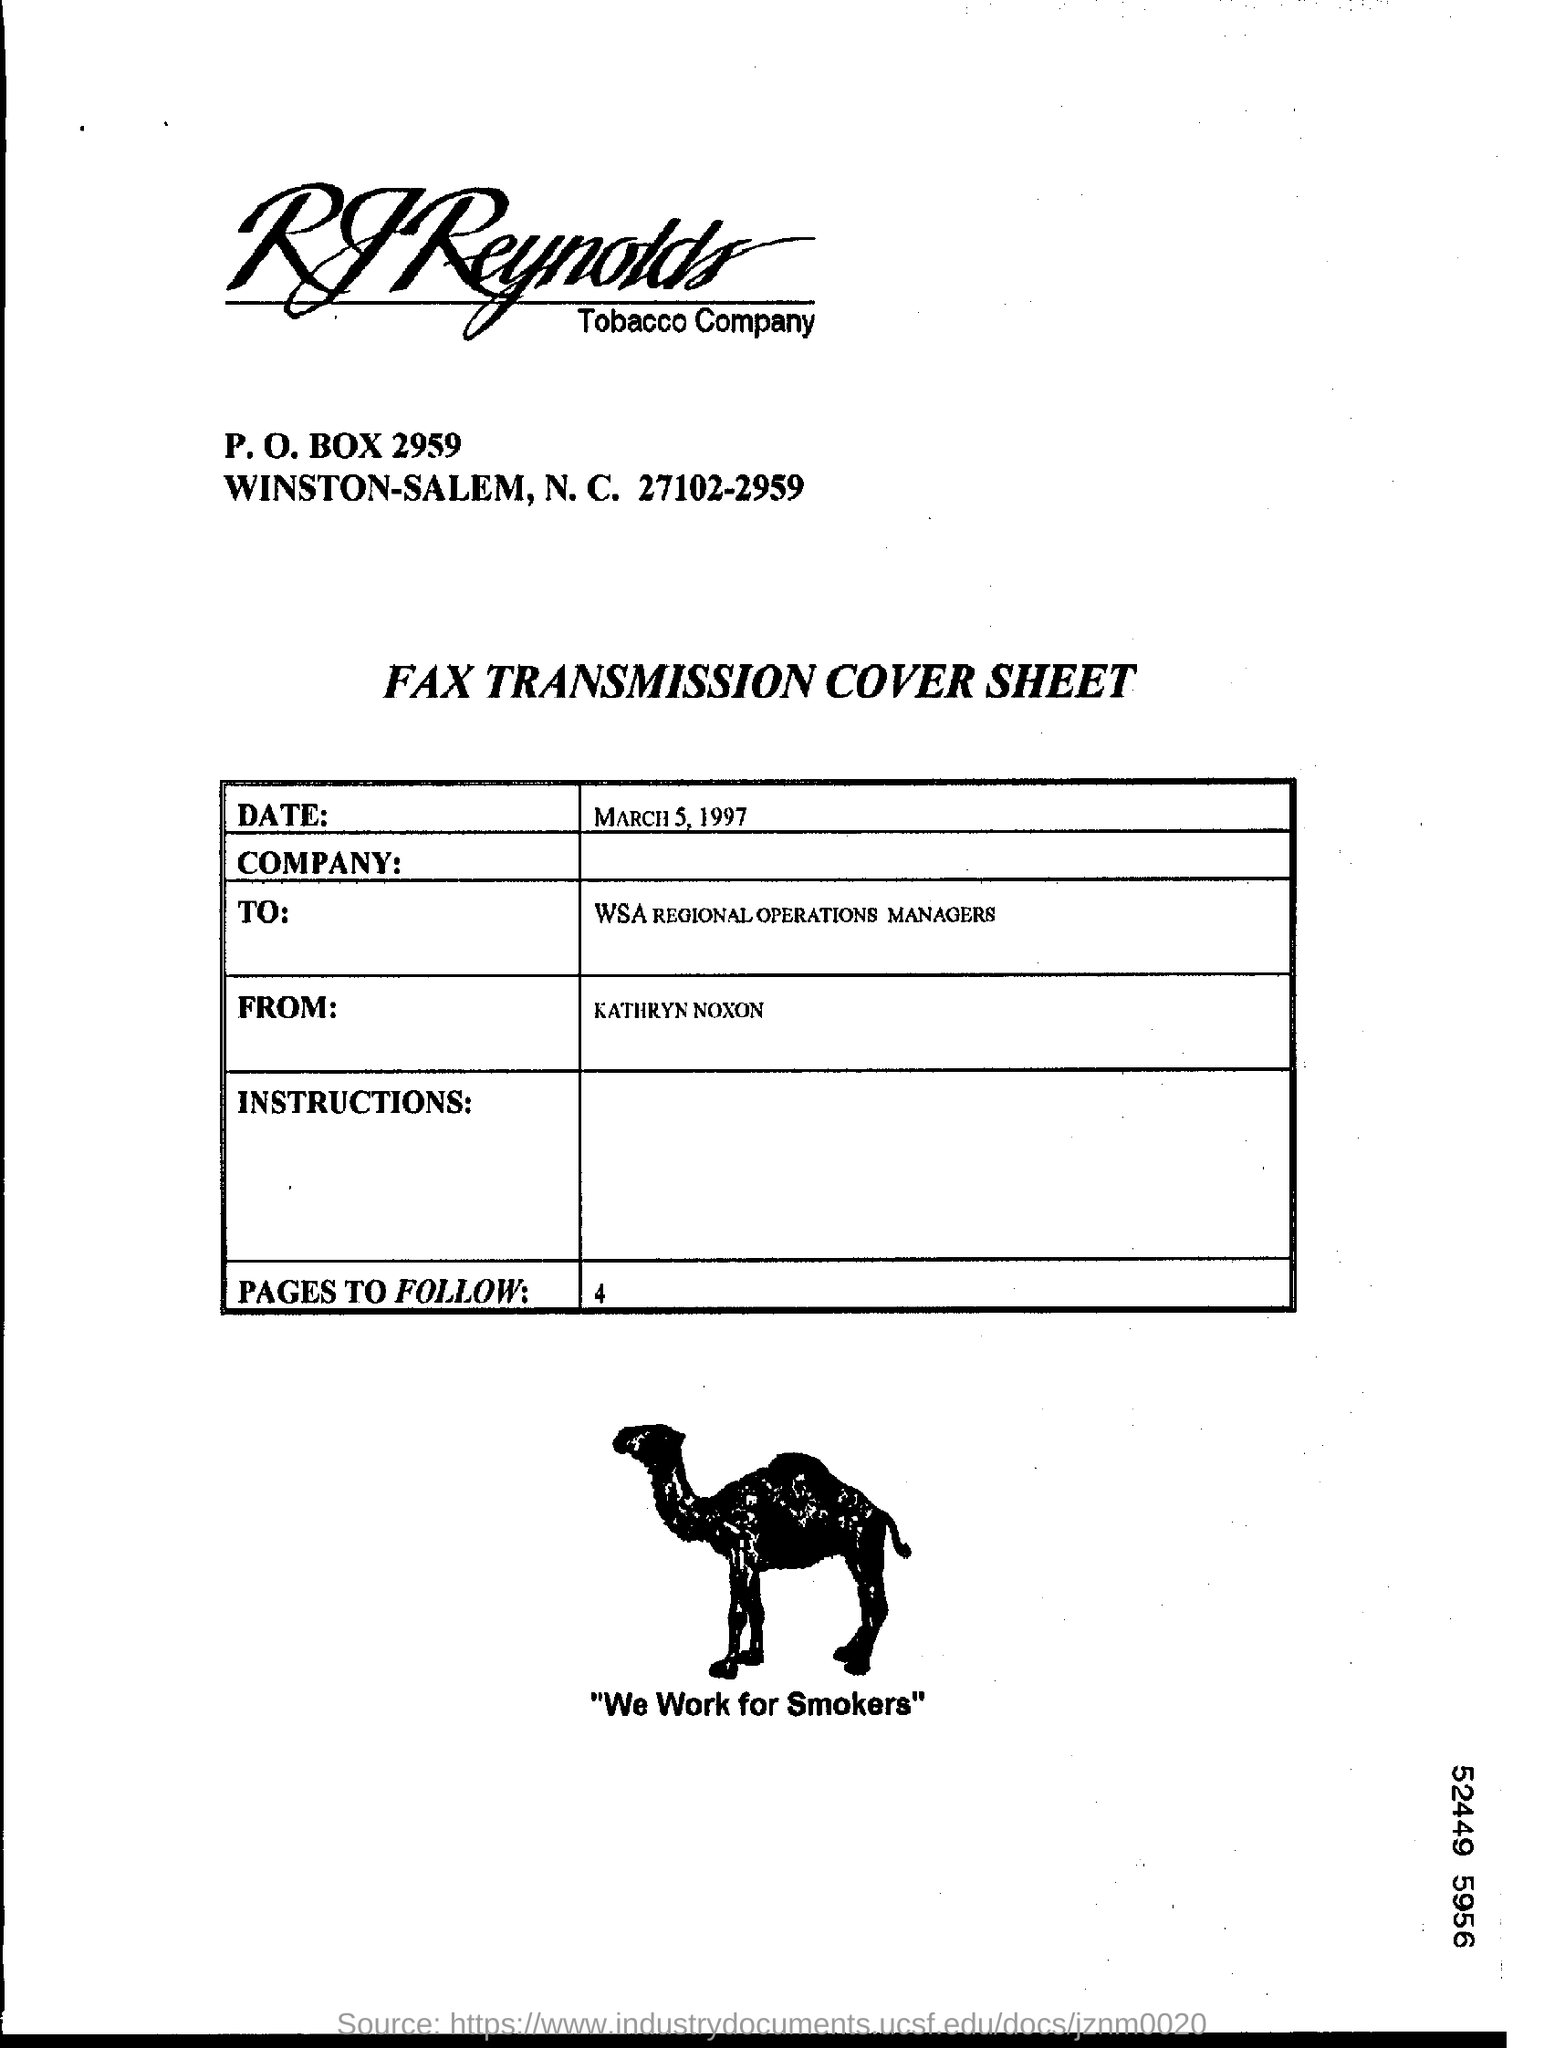Who is the sender of this fax?
Provide a short and direct response. KATHRYN NOXON. Which date is mentioned on the cover sheet ?
Keep it short and to the point. MARCH 5, 1997. Who wrote this cover sheet ?
Offer a very short reply. KATHRYN NOXON. To whom this fax trasmission cover sheet written ?
Give a very brief answer. WSA REGIONAL OPERATIONS MANAGERs. Number of pages to follow ?
Your answer should be very brief. 4. 